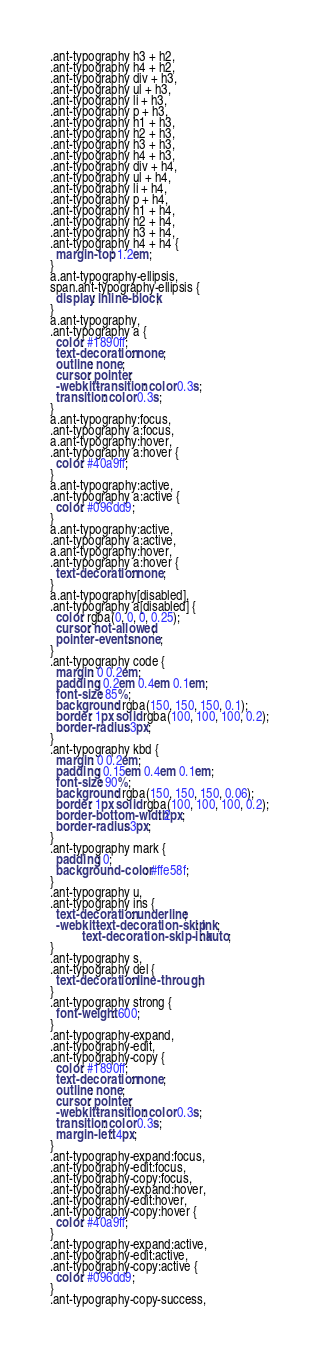<code> <loc_0><loc_0><loc_500><loc_500><_CSS_>.ant-typography h3 + h2,
.ant-typography h4 + h2,
.ant-typography div + h3,
.ant-typography ul + h3,
.ant-typography li + h3,
.ant-typography p + h3,
.ant-typography h1 + h3,
.ant-typography h2 + h3,
.ant-typography h3 + h3,
.ant-typography h4 + h3,
.ant-typography div + h4,
.ant-typography ul + h4,
.ant-typography li + h4,
.ant-typography p + h4,
.ant-typography h1 + h4,
.ant-typography h2 + h4,
.ant-typography h3 + h4,
.ant-typography h4 + h4 {
  margin-top: 1.2em;
}
a.ant-typography-ellipsis,
span.ant-typography-ellipsis {
  display: inline-block;
}
a.ant-typography,
.ant-typography a {
  color: #1890ff;
  text-decoration: none;
  outline: none;
  cursor: pointer;
  -webkit-transition: color 0.3s;
  transition: color 0.3s;
}
a.ant-typography:focus,
.ant-typography a:focus,
a.ant-typography:hover,
.ant-typography a:hover {
  color: #40a9ff;
}
a.ant-typography:active,
.ant-typography a:active {
  color: #096dd9;
}
a.ant-typography:active,
.ant-typography a:active,
a.ant-typography:hover,
.ant-typography a:hover {
  text-decoration: none;
}
a.ant-typography[disabled],
.ant-typography a[disabled] {
  color: rgba(0, 0, 0, 0.25);
  cursor: not-allowed;
  pointer-events: none;
}
.ant-typography code {
  margin: 0 0.2em;
  padding: 0.2em 0.4em 0.1em;
  font-size: 85%;
  background: rgba(150, 150, 150, 0.1);
  border: 1px solid rgba(100, 100, 100, 0.2);
  border-radius: 3px;
}
.ant-typography kbd {
  margin: 0 0.2em;
  padding: 0.15em 0.4em 0.1em;
  font-size: 90%;
  background: rgba(150, 150, 150, 0.06);
  border: 1px solid rgba(100, 100, 100, 0.2);
  border-bottom-width: 2px;
  border-radius: 3px;
}
.ant-typography mark {
  padding: 0;
  background-color: #ffe58f;
}
.ant-typography u,
.ant-typography ins {
  text-decoration: underline;
  -webkit-text-decoration-skip: ink;
          text-decoration-skip-ink: auto;
}
.ant-typography s,
.ant-typography del {
  text-decoration: line-through;
}
.ant-typography strong {
  font-weight: 600;
}
.ant-typography-expand,
.ant-typography-edit,
.ant-typography-copy {
  color: #1890ff;
  text-decoration: none;
  outline: none;
  cursor: pointer;
  -webkit-transition: color 0.3s;
  transition: color 0.3s;
  margin-left: 4px;
}
.ant-typography-expand:focus,
.ant-typography-edit:focus,
.ant-typography-copy:focus,
.ant-typography-expand:hover,
.ant-typography-edit:hover,
.ant-typography-copy:hover {
  color: #40a9ff;
}
.ant-typography-expand:active,
.ant-typography-edit:active,
.ant-typography-copy:active {
  color: #096dd9;
}
.ant-typography-copy-success,</code> 